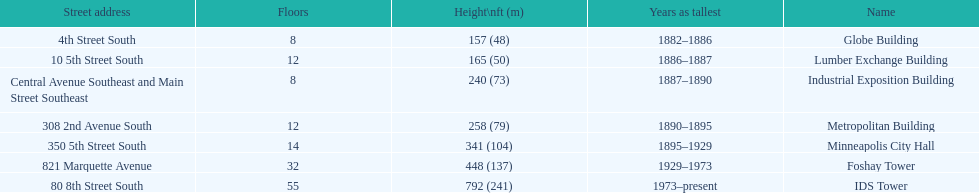What was the first building named as the tallest? Globe Building. 